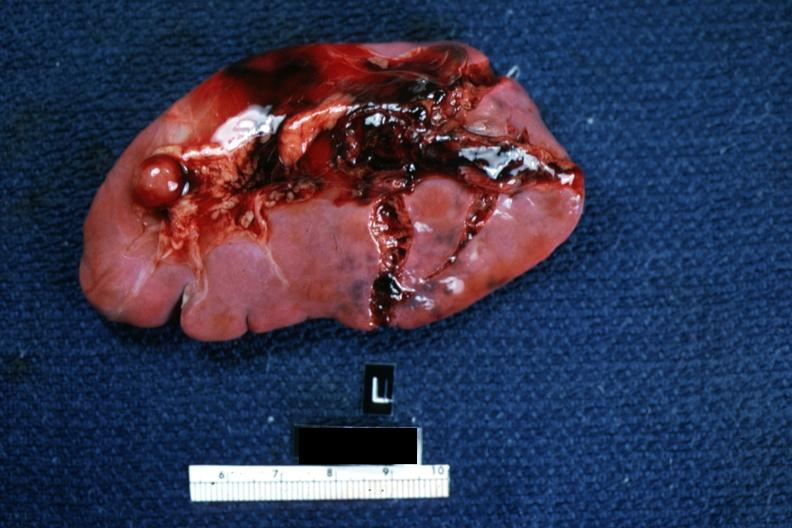s very good example present?
Answer the question using a single word or phrase. No 